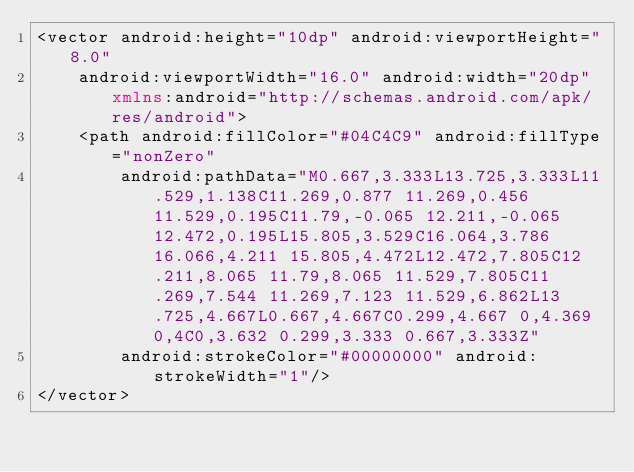Convert code to text. <code><loc_0><loc_0><loc_500><loc_500><_XML_><vector android:height="10dp" android:viewportHeight="8.0"
    android:viewportWidth="16.0" android:width="20dp" xmlns:android="http://schemas.android.com/apk/res/android">
    <path android:fillColor="#04C4C9" android:fillType="nonZero"
        android:pathData="M0.667,3.333L13.725,3.333L11.529,1.138C11.269,0.877 11.269,0.456 11.529,0.195C11.79,-0.065 12.211,-0.065 12.472,0.195L15.805,3.529C16.064,3.786 16.066,4.211 15.805,4.472L12.472,7.805C12.211,8.065 11.79,8.065 11.529,7.805C11.269,7.544 11.269,7.123 11.529,6.862L13.725,4.667L0.667,4.667C0.299,4.667 0,4.369 0,4C0,3.632 0.299,3.333 0.667,3.333Z"
        android:strokeColor="#00000000" android:strokeWidth="1"/>
</vector>
</code> 